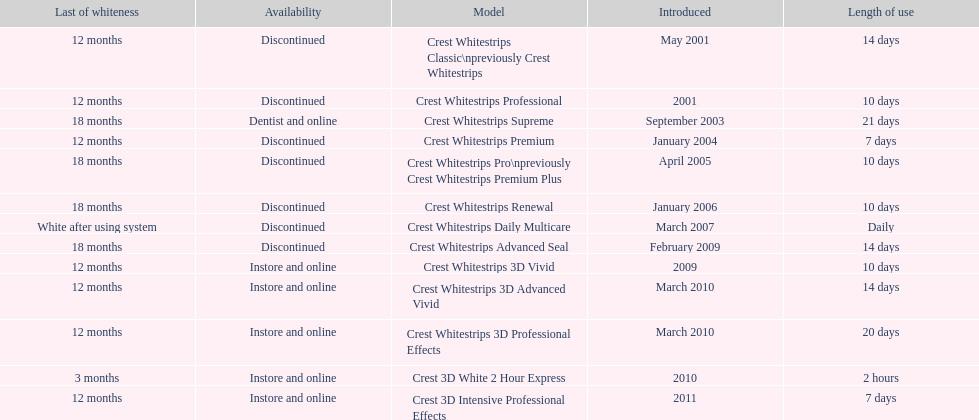Is each white strip discontinued? No. 